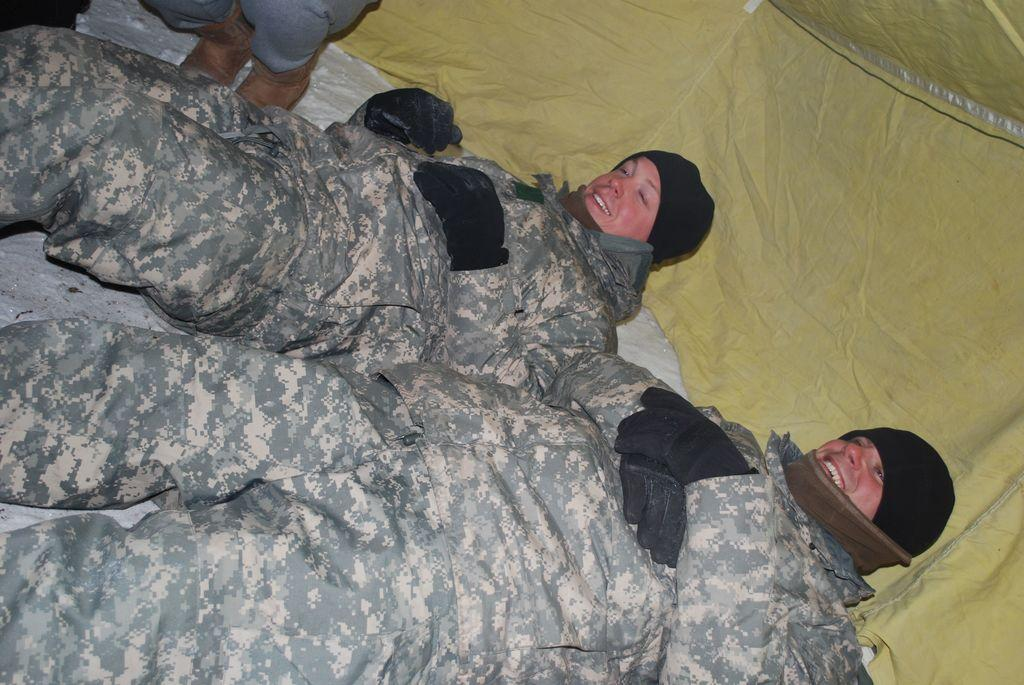How many people are lying down in the image? There are two persons lying down in the image. What is the position of the third person in the image? There is a person sitting on their knees in the image. Where does the scene take place? The scene takes place inside a tent. How many letters are visible on the cent in the image? There is no cent or any letters on it present in the image. 